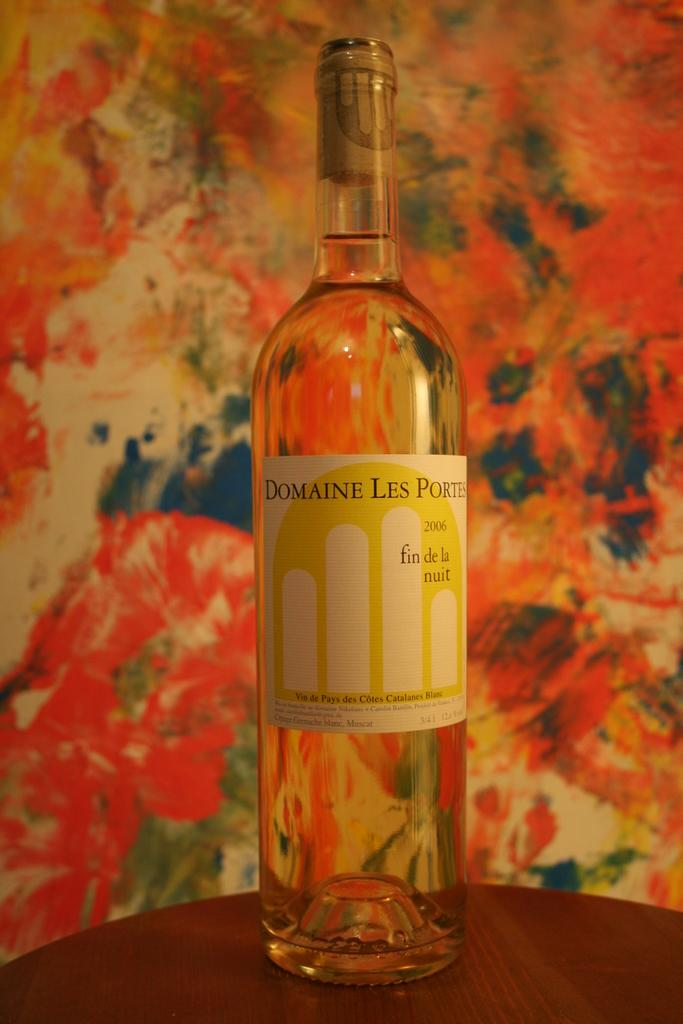<image>
Relay a brief, clear account of the picture shown. Bottle of Domaine Les Ports that is full and never open 